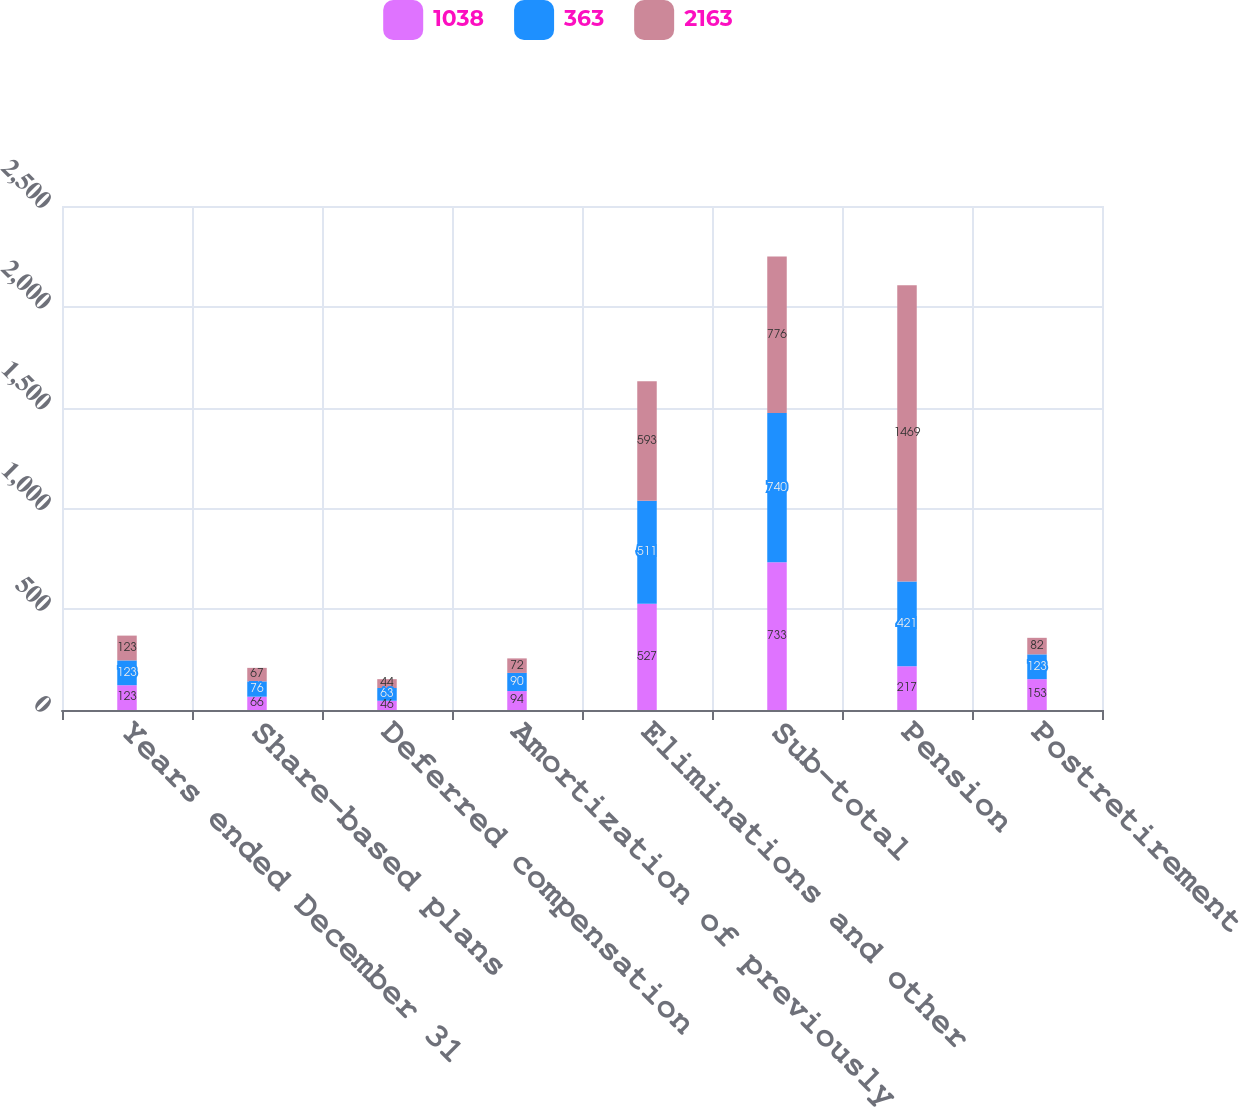<chart> <loc_0><loc_0><loc_500><loc_500><stacked_bar_chart><ecel><fcel>Years ended December 31<fcel>Share-based plans<fcel>Deferred compensation<fcel>Amortization of previously<fcel>Eliminations and other<fcel>Sub-total<fcel>Pension<fcel>Postretirement<nl><fcel>1038<fcel>123<fcel>66<fcel>46<fcel>94<fcel>527<fcel>733<fcel>217<fcel>153<nl><fcel>363<fcel>123<fcel>76<fcel>63<fcel>90<fcel>511<fcel>740<fcel>421<fcel>123<nl><fcel>2163<fcel>123<fcel>67<fcel>44<fcel>72<fcel>593<fcel>776<fcel>1469<fcel>82<nl></chart> 